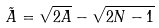<formula> <loc_0><loc_0><loc_500><loc_500>\tilde { A } = \sqrt { 2 A } - \sqrt { 2 N - 1 }</formula> 